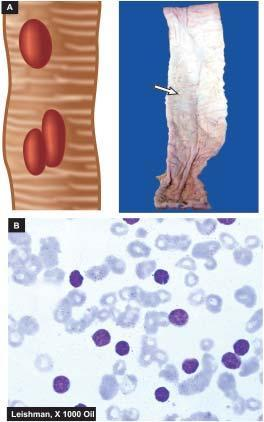what appear characteristically oval with their long axis parallel to the long axis of the bowel?
Answer the question using a single word or phrase. Typhoid ulcers in the small intestine 